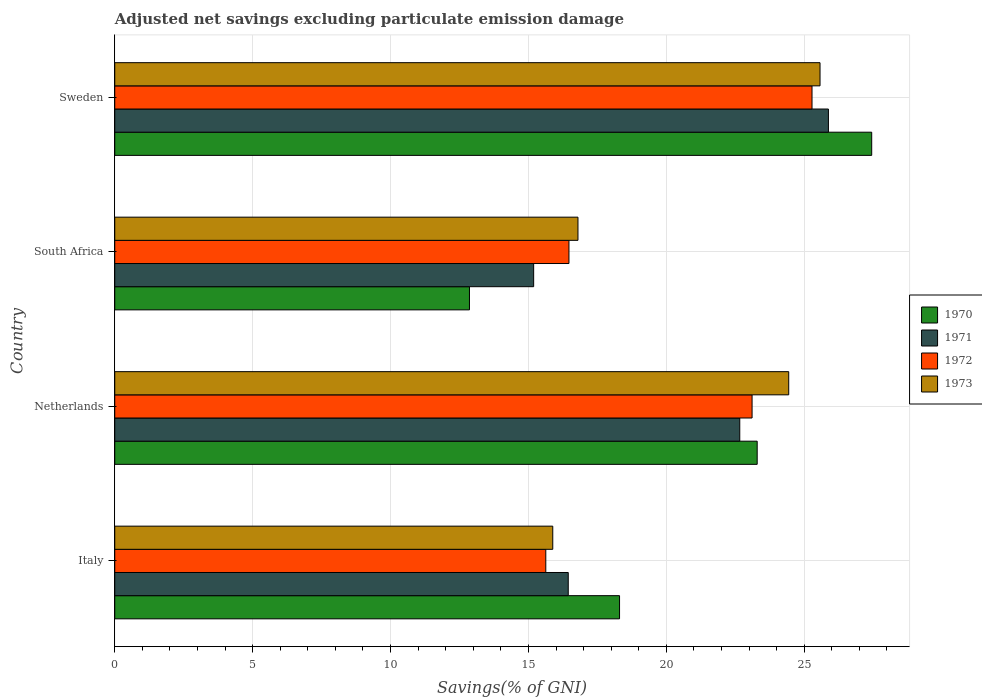How many different coloured bars are there?
Your response must be concise. 4. Are the number of bars on each tick of the Y-axis equal?
Give a very brief answer. Yes. How many bars are there on the 2nd tick from the top?
Your answer should be compact. 4. How many bars are there on the 1st tick from the bottom?
Your answer should be compact. 4. In how many cases, is the number of bars for a given country not equal to the number of legend labels?
Your answer should be very brief. 0. What is the adjusted net savings in 1971 in South Africa?
Provide a succinct answer. 15.19. Across all countries, what is the maximum adjusted net savings in 1970?
Provide a short and direct response. 27.45. Across all countries, what is the minimum adjusted net savings in 1973?
Provide a short and direct response. 15.88. In which country was the adjusted net savings in 1970 maximum?
Offer a terse response. Sweden. In which country was the adjusted net savings in 1971 minimum?
Make the answer very short. South Africa. What is the total adjusted net savings in 1971 in the graph?
Offer a terse response. 80.18. What is the difference between the adjusted net savings in 1971 in South Africa and that in Sweden?
Provide a short and direct response. -10.69. What is the difference between the adjusted net savings in 1970 in Italy and the adjusted net savings in 1971 in South Africa?
Your answer should be very brief. 3.11. What is the average adjusted net savings in 1970 per country?
Your answer should be very brief. 20.48. What is the difference between the adjusted net savings in 1970 and adjusted net savings in 1973 in Netherlands?
Provide a succinct answer. -1.14. What is the ratio of the adjusted net savings in 1970 in Italy to that in South Africa?
Offer a very short reply. 1.42. What is the difference between the highest and the second highest adjusted net savings in 1972?
Your response must be concise. 2.17. What is the difference between the highest and the lowest adjusted net savings in 1973?
Make the answer very short. 9.69. Is the sum of the adjusted net savings in 1970 in Italy and South Africa greater than the maximum adjusted net savings in 1972 across all countries?
Keep it short and to the point. Yes. What does the 4th bar from the top in Netherlands represents?
Offer a very short reply. 1970. What does the 4th bar from the bottom in Italy represents?
Make the answer very short. 1973. Are all the bars in the graph horizontal?
Your answer should be very brief. Yes. How many countries are there in the graph?
Your response must be concise. 4. What is the difference between two consecutive major ticks on the X-axis?
Give a very brief answer. 5. Where does the legend appear in the graph?
Provide a short and direct response. Center right. How many legend labels are there?
Ensure brevity in your answer.  4. What is the title of the graph?
Keep it short and to the point. Adjusted net savings excluding particulate emission damage. What is the label or title of the X-axis?
Make the answer very short. Savings(% of GNI). What is the Savings(% of GNI) of 1970 in Italy?
Ensure brevity in your answer.  18.3. What is the Savings(% of GNI) of 1971 in Italy?
Keep it short and to the point. 16.44. What is the Savings(% of GNI) in 1972 in Italy?
Offer a terse response. 15.63. What is the Savings(% of GNI) of 1973 in Italy?
Offer a very short reply. 15.88. What is the Savings(% of GNI) of 1970 in Netherlands?
Your answer should be compact. 23.3. What is the Savings(% of GNI) in 1971 in Netherlands?
Your response must be concise. 22.66. What is the Savings(% of GNI) of 1972 in Netherlands?
Give a very brief answer. 23.11. What is the Savings(% of GNI) in 1973 in Netherlands?
Make the answer very short. 24.44. What is the Savings(% of GNI) of 1970 in South Africa?
Make the answer very short. 12.86. What is the Savings(% of GNI) in 1971 in South Africa?
Ensure brevity in your answer.  15.19. What is the Savings(% of GNI) in 1972 in South Africa?
Your answer should be compact. 16.47. What is the Savings(% of GNI) in 1973 in South Africa?
Give a very brief answer. 16.8. What is the Savings(% of GNI) of 1970 in Sweden?
Give a very brief answer. 27.45. What is the Savings(% of GNI) of 1971 in Sweden?
Provide a short and direct response. 25.88. What is the Savings(% of GNI) of 1972 in Sweden?
Offer a very short reply. 25.28. What is the Savings(% of GNI) in 1973 in Sweden?
Keep it short and to the point. 25.57. Across all countries, what is the maximum Savings(% of GNI) in 1970?
Make the answer very short. 27.45. Across all countries, what is the maximum Savings(% of GNI) of 1971?
Provide a short and direct response. 25.88. Across all countries, what is the maximum Savings(% of GNI) in 1972?
Provide a succinct answer. 25.28. Across all countries, what is the maximum Savings(% of GNI) of 1973?
Keep it short and to the point. 25.57. Across all countries, what is the minimum Savings(% of GNI) of 1970?
Provide a short and direct response. 12.86. Across all countries, what is the minimum Savings(% of GNI) of 1971?
Provide a succinct answer. 15.19. Across all countries, what is the minimum Savings(% of GNI) in 1972?
Keep it short and to the point. 15.63. Across all countries, what is the minimum Savings(% of GNI) in 1973?
Ensure brevity in your answer.  15.88. What is the total Savings(% of GNI) in 1970 in the graph?
Offer a terse response. 81.91. What is the total Savings(% of GNI) in 1971 in the graph?
Your answer should be compact. 80.18. What is the total Savings(% of GNI) in 1972 in the graph?
Provide a succinct answer. 80.49. What is the total Savings(% of GNI) of 1973 in the graph?
Keep it short and to the point. 82.69. What is the difference between the Savings(% of GNI) of 1970 in Italy and that in Netherlands?
Ensure brevity in your answer.  -4.99. What is the difference between the Savings(% of GNI) of 1971 in Italy and that in Netherlands?
Ensure brevity in your answer.  -6.22. What is the difference between the Savings(% of GNI) of 1972 in Italy and that in Netherlands?
Ensure brevity in your answer.  -7.48. What is the difference between the Savings(% of GNI) of 1973 in Italy and that in Netherlands?
Your answer should be very brief. -8.56. What is the difference between the Savings(% of GNI) in 1970 in Italy and that in South Africa?
Your answer should be compact. 5.44. What is the difference between the Savings(% of GNI) in 1971 in Italy and that in South Africa?
Offer a very short reply. 1.25. What is the difference between the Savings(% of GNI) of 1972 in Italy and that in South Africa?
Offer a terse response. -0.84. What is the difference between the Savings(% of GNI) in 1973 in Italy and that in South Africa?
Your response must be concise. -0.91. What is the difference between the Savings(% of GNI) in 1970 in Italy and that in Sweden?
Offer a very short reply. -9.14. What is the difference between the Savings(% of GNI) in 1971 in Italy and that in Sweden?
Offer a terse response. -9.43. What is the difference between the Savings(% of GNI) in 1972 in Italy and that in Sweden?
Your response must be concise. -9.65. What is the difference between the Savings(% of GNI) in 1973 in Italy and that in Sweden?
Your answer should be very brief. -9.69. What is the difference between the Savings(% of GNI) in 1970 in Netherlands and that in South Africa?
Make the answer very short. 10.43. What is the difference between the Savings(% of GNI) of 1971 in Netherlands and that in South Africa?
Ensure brevity in your answer.  7.47. What is the difference between the Savings(% of GNI) of 1972 in Netherlands and that in South Africa?
Keep it short and to the point. 6.64. What is the difference between the Savings(% of GNI) in 1973 in Netherlands and that in South Africa?
Offer a very short reply. 7.64. What is the difference between the Savings(% of GNI) in 1970 in Netherlands and that in Sweden?
Provide a short and direct response. -4.15. What is the difference between the Savings(% of GNI) of 1971 in Netherlands and that in Sweden?
Provide a short and direct response. -3.21. What is the difference between the Savings(% of GNI) in 1972 in Netherlands and that in Sweden?
Offer a terse response. -2.17. What is the difference between the Savings(% of GNI) in 1973 in Netherlands and that in Sweden?
Make the answer very short. -1.14. What is the difference between the Savings(% of GNI) in 1970 in South Africa and that in Sweden?
Your answer should be compact. -14.59. What is the difference between the Savings(% of GNI) of 1971 in South Africa and that in Sweden?
Offer a very short reply. -10.69. What is the difference between the Savings(% of GNI) of 1972 in South Africa and that in Sweden?
Keep it short and to the point. -8.81. What is the difference between the Savings(% of GNI) in 1973 in South Africa and that in Sweden?
Offer a very short reply. -8.78. What is the difference between the Savings(% of GNI) of 1970 in Italy and the Savings(% of GNI) of 1971 in Netherlands?
Offer a terse response. -4.36. What is the difference between the Savings(% of GNI) of 1970 in Italy and the Savings(% of GNI) of 1972 in Netherlands?
Keep it short and to the point. -4.81. What is the difference between the Savings(% of GNI) of 1970 in Italy and the Savings(% of GNI) of 1973 in Netherlands?
Your answer should be very brief. -6.13. What is the difference between the Savings(% of GNI) of 1971 in Italy and the Savings(% of GNI) of 1972 in Netherlands?
Offer a terse response. -6.67. What is the difference between the Savings(% of GNI) of 1971 in Italy and the Savings(% of GNI) of 1973 in Netherlands?
Ensure brevity in your answer.  -7.99. What is the difference between the Savings(% of GNI) in 1972 in Italy and the Savings(% of GNI) in 1973 in Netherlands?
Ensure brevity in your answer.  -8.81. What is the difference between the Savings(% of GNI) in 1970 in Italy and the Savings(% of GNI) in 1971 in South Africa?
Provide a succinct answer. 3.11. What is the difference between the Savings(% of GNI) in 1970 in Italy and the Savings(% of GNI) in 1972 in South Africa?
Provide a short and direct response. 1.83. What is the difference between the Savings(% of GNI) in 1970 in Italy and the Savings(% of GNI) in 1973 in South Africa?
Offer a very short reply. 1.51. What is the difference between the Savings(% of GNI) in 1971 in Italy and the Savings(% of GNI) in 1972 in South Africa?
Your answer should be very brief. -0.03. What is the difference between the Savings(% of GNI) in 1971 in Italy and the Savings(% of GNI) in 1973 in South Africa?
Your response must be concise. -0.35. What is the difference between the Savings(% of GNI) of 1972 in Italy and the Savings(% of GNI) of 1973 in South Africa?
Give a very brief answer. -1.17. What is the difference between the Savings(% of GNI) in 1970 in Italy and the Savings(% of GNI) in 1971 in Sweden?
Offer a terse response. -7.57. What is the difference between the Savings(% of GNI) of 1970 in Italy and the Savings(% of GNI) of 1972 in Sweden?
Offer a very short reply. -6.98. What is the difference between the Savings(% of GNI) of 1970 in Italy and the Savings(% of GNI) of 1973 in Sweden?
Your answer should be compact. -7.27. What is the difference between the Savings(% of GNI) in 1971 in Italy and the Savings(% of GNI) in 1972 in Sweden?
Keep it short and to the point. -8.84. What is the difference between the Savings(% of GNI) of 1971 in Italy and the Savings(% of GNI) of 1973 in Sweden?
Provide a succinct answer. -9.13. What is the difference between the Savings(% of GNI) in 1972 in Italy and the Savings(% of GNI) in 1973 in Sweden?
Provide a short and direct response. -9.94. What is the difference between the Savings(% of GNI) of 1970 in Netherlands and the Savings(% of GNI) of 1971 in South Africa?
Offer a very short reply. 8.11. What is the difference between the Savings(% of GNI) of 1970 in Netherlands and the Savings(% of GNI) of 1972 in South Africa?
Offer a terse response. 6.83. What is the difference between the Savings(% of GNI) in 1970 in Netherlands and the Savings(% of GNI) in 1973 in South Africa?
Your answer should be very brief. 6.5. What is the difference between the Savings(% of GNI) in 1971 in Netherlands and the Savings(% of GNI) in 1972 in South Africa?
Keep it short and to the point. 6.19. What is the difference between the Savings(% of GNI) of 1971 in Netherlands and the Savings(% of GNI) of 1973 in South Africa?
Provide a succinct answer. 5.87. What is the difference between the Savings(% of GNI) of 1972 in Netherlands and the Savings(% of GNI) of 1973 in South Africa?
Ensure brevity in your answer.  6.31. What is the difference between the Savings(% of GNI) of 1970 in Netherlands and the Savings(% of GNI) of 1971 in Sweden?
Offer a very short reply. -2.58. What is the difference between the Savings(% of GNI) of 1970 in Netherlands and the Savings(% of GNI) of 1972 in Sweden?
Ensure brevity in your answer.  -1.99. What is the difference between the Savings(% of GNI) of 1970 in Netherlands and the Savings(% of GNI) of 1973 in Sweden?
Provide a succinct answer. -2.28. What is the difference between the Savings(% of GNI) of 1971 in Netherlands and the Savings(% of GNI) of 1972 in Sweden?
Your answer should be compact. -2.62. What is the difference between the Savings(% of GNI) of 1971 in Netherlands and the Savings(% of GNI) of 1973 in Sweden?
Offer a very short reply. -2.91. What is the difference between the Savings(% of GNI) in 1972 in Netherlands and the Savings(% of GNI) in 1973 in Sweden?
Offer a terse response. -2.46. What is the difference between the Savings(% of GNI) of 1970 in South Africa and the Savings(% of GNI) of 1971 in Sweden?
Make the answer very short. -13.02. What is the difference between the Savings(% of GNI) in 1970 in South Africa and the Savings(% of GNI) in 1972 in Sweden?
Your answer should be compact. -12.42. What is the difference between the Savings(% of GNI) in 1970 in South Africa and the Savings(% of GNI) in 1973 in Sweden?
Your response must be concise. -12.71. What is the difference between the Savings(% of GNI) of 1971 in South Africa and the Savings(% of GNI) of 1972 in Sweden?
Make the answer very short. -10.09. What is the difference between the Savings(% of GNI) in 1971 in South Africa and the Savings(% of GNI) in 1973 in Sweden?
Ensure brevity in your answer.  -10.38. What is the difference between the Savings(% of GNI) of 1972 in South Africa and the Savings(% of GNI) of 1973 in Sweden?
Your answer should be very brief. -9.1. What is the average Savings(% of GNI) of 1970 per country?
Offer a very short reply. 20.48. What is the average Savings(% of GNI) of 1971 per country?
Keep it short and to the point. 20.04. What is the average Savings(% of GNI) of 1972 per country?
Your response must be concise. 20.12. What is the average Savings(% of GNI) of 1973 per country?
Your answer should be compact. 20.67. What is the difference between the Savings(% of GNI) of 1970 and Savings(% of GNI) of 1971 in Italy?
Your answer should be very brief. 1.86. What is the difference between the Savings(% of GNI) in 1970 and Savings(% of GNI) in 1972 in Italy?
Keep it short and to the point. 2.67. What is the difference between the Savings(% of GNI) of 1970 and Savings(% of GNI) of 1973 in Italy?
Give a very brief answer. 2.42. What is the difference between the Savings(% of GNI) in 1971 and Savings(% of GNI) in 1972 in Italy?
Offer a terse response. 0.81. What is the difference between the Savings(% of GNI) of 1971 and Savings(% of GNI) of 1973 in Italy?
Ensure brevity in your answer.  0.56. What is the difference between the Savings(% of GNI) in 1972 and Savings(% of GNI) in 1973 in Italy?
Provide a succinct answer. -0.25. What is the difference between the Savings(% of GNI) in 1970 and Savings(% of GNI) in 1971 in Netherlands?
Provide a succinct answer. 0.63. What is the difference between the Savings(% of GNI) in 1970 and Savings(% of GNI) in 1972 in Netherlands?
Provide a succinct answer. 0.19. What is the difference between the Savings(% of GNI) in 1970 and Savings(% of GNI) in 1973 in Netherlands?
Provide a succinct answer. -1.14. What is the difference between the Savings(% of GNI) in 1971 and Savings(% of GNI) in 1972 in Netherlands?
Your response must be concise. -0.45. What is the difference between the Savings(% of GNI) of 1971 and Savings(% of GNI) of 1973 in Netherlands?
Offer a terse response. -1.77. What is the difference between the Savings(% of GNI) in 1972 and Savings(% of GNI) in 1973 in Netherlands?
Provide a succinct answer. -1.33. What is the difference between the Savings(% of GNI) of 1970 and Savings(% of GNI) of 1971 in South Africa?
Provide a succinct answer. -2.33. What is the difference between the Savings(% of GNI) in 1970 and Savings(% of GNI) in 1972 in South Africa?
Your answer should be compact. -3.61. What is the difference between the Savings(% of GNI) of 1970 and Savings(% of GNI) of 1973 in South Africa?
Offer a very short reply. -3.93. What is the difference between the Savings(% of GNI) in 1971 and Savings(% of GNI) in 1972 in South Africa?
Provide a succinct answer. -1.28. What is the difference between the Savings(% of GNI) in 1971 and Savings(% of GNI) in 1973 in South Africa?
Your answer should be compact. -1.61. What is the difference between the Savings(% of GNI) of 1972 and Savings(% of GNI) of 1973 in South Africa?
Give a very brief answer. -0.33. What is the difference between the Savings(% of GNI) of 1970 and Savings(% of GNI) of 1971 in Sweden?
Your response must be concise. 1.57. What is the difference between the Savings(% of GNI) of 1970 and Savings(% of GNI) of 1972 in Sweden?
Keep it short and to the point. 2.16. What is the difference between the Savings(% of GNI) in 1970 and Savings(% of GNI) in 1973 in Sweden?
Your answer should be compact. 1.87. What is the difference between the Savings(% of GNI) of 1971 and Savings(% of GNI) of 1972 in Sweden?
Make the answer very short. 0.59. What is the difference between the Savings(% of GNI) in 1971 and Savings(% of GNI) in 1973 in Sweden?
Your answer should be very brief. 0.3. What is the difference between the Savings(% of GNI) of 1972 and Savings(% of GNI) of 1973 in Sweden?
Your answer should be compact. -0.29. What is the ratio of the Savings(% of GNI) of 1970 in Italy to that in Netherlands?
Provide a short and direct response. 0.79. What is the ratio of the Savings(% of GNI) in 1971 in Italy to that in Netherlands?
Give a very brief answer. 0.73. What is the ratio of the Savings(% of GNI) in 1972 in Italy to that in Netherlands?
Provide a short and direct response. 0.68. What is the ratio of the Savings(% of GNI) of 1973 in Italy to that in Netherlands?
Provide a short and direct response. 0.65. What is the ratio of the Savings(% of GNI) of 1970 in Italy to that in South Africa?
Give a very brief answer. 1.42. What is the ratio of the Savings(% of GNI) of 1971 in Italy to that in South Africa?
Make the answer very short. 1.08. What is the ratio of the Savings(% of GNI) of 1972 in Italy to that in South Africa?
Offer a terse response. 0.95. What is the ratio of the Savings(% of GNI) of 1973 in Italy to that in South Africa?
Your answer should be very brief. 0.95. What is the ratio of the Savings(% of GNI) in 1970 in Italy to that in Sweden?
Your response must be concise. 0.67. What is the ratio of the Savings(% of GNI) of 1971 in Italy to that in Sweden?
Provide a succinct answer. 0.64. What is the ratio of the Savings(% of GNI) in 1972 in Italy to that in Sweden?
Give a very brief answer. 0.62. What is the ratio of the Savings(% of GNI) in 1973 in Italy to that in Sweden?
Ensure brevity in your answer.  0.62. What is the ratio of the Savings(% of GNI) of 1970 in Netherlands to that in South Africa?
Your answer should be very brief. 1.81. What is the ratio of the Savings(% of GNI) of 1971 in Netherlands to that in South Africa?
Give a very brief answer. 1.49. What is the ratio of the Savings(% of GNI) in 1972 in Netherlands to that in South Africa?
Ensure brevity in your answer.  1.4. What is the ratio of the Savings(% of GNI) of 1973 in Netherlands to that in South Africa?
Your answer should be compact. 1.46. What is the ratio of the Savings(% of GNI) in 1970 in Netherlands to that in Sweden?
Your answer should be compact. 0.85. What is the ratio of the Savings(% of GNI) in 1971 in Netherlands to that in Sweden?
Offer a very short reply. 0.88. What is the ratio of the Savings(% of GNI) in 1972 in Netherlands to that in Sweden?
Your response must be concise. 0.91. What is the ratio of the Savings(% of GNI) of 1973 in Netherlands to that in Sweden?
Your answer should be compact. 0.96. What is the ratio of the Savings(% of GNI) in 1970 in South Africa to that in Sweden?
Give a very brief answer. 0.47. What is the ratio of the Savings(% of GNI) in 1971 in South Africa to that in Sweden?
Offer a very short reply. 0.59. What is the ratio of the Savings(% of GNI) in 1972 in South Africa to that in Sweden?
Offer a terse response. 0.65. What is the ratio of the Savings(% of GNI) in 1973 in South Africa to that in Sweden?
Keep it short and to the point. 0.66. What is the difference between the highest and the second highest Savings(% of GNI) of 1970?
Keep it short and to the point. 4.15. What is the difference between the highest and the second highest Savings(% of GNI) of 1971?
Your answer should be very brief. 3.21. What is the difference between the highest and the second highest Savings(% of GNI) of 1972?
Offer a very short reply. 2.17. What is the difference between the highest and the second highest Savings(% of GNI) in 1973?
Ensure brevity in your answer.  1.14. What is the difference between the highest and the lowest Savings(% of GNI) of 1970?
Offer a very short reply. 14.59. What is the difference between the highest and the lowest Savings(% of GNI) of 1971?
Your answer should be compact. 10.69. What is the difference between the highest and the lowest Savings(% of GNI) in 1972?
Offer a very short reply. 9.65. What is the difference between the highest and the lowest Savings(% of GNI) in 1973?
Give a very brief answer. 9.69. 